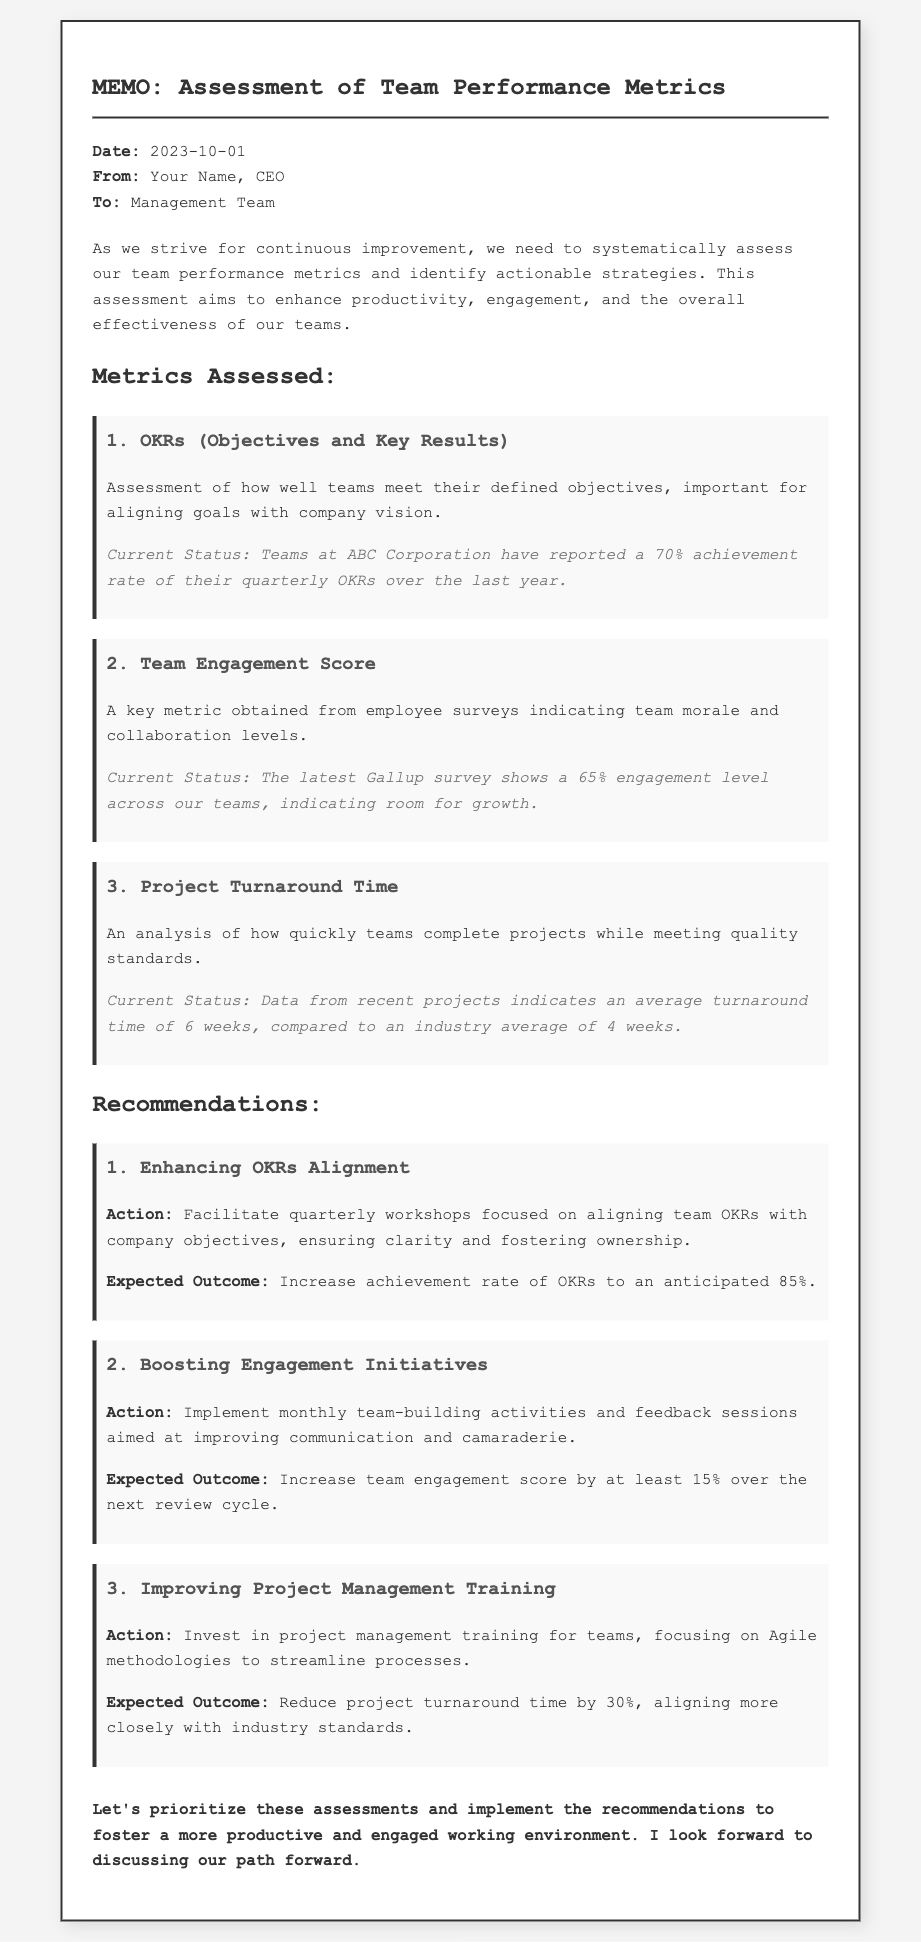what is the date of the memo? The date specified in the memo is clearly stated at the top, following the "Date:" label.
Answer: 2023-10-01 who is the sender of the memo? The sender of the memo is mentioned under the "From:" label in the header section.
Answer: Your Name what is the current achievement rate of OKRs? The current achievement rate is provided in the section detailing the OKRs performance metric.
Answer: 70% what is the engagement level indicated by the Gallup survey? The engagement level is mentioned within the Team Engagement Score section of the document.
Answer: 65% what is the average project turnaround time stated in the memo? The average turnaround time can be found in the Project Turnaround Time metric analysis.
Answer: 6 weeks what is the expected outcome of enhancing OKRs alignment? The expected outcome from the recommendations section describes the potential benefit of the OKR alignment action.
Answer: 85% what action is recommended to boost engagement initiatives? The memo specifically outlines actions to improve team engagement under the recommendations section.
Answer: Monthly team-building activities how much reduction in project turnaround time is anticipated through training? This anticipated reduction is specified in the recommendation for project management training.
Answer: 30% what is the primary aim of the memo? The main objective of the memo is articulated right at the beginning, outlining its purpose.
Answer: Continuous improvement 